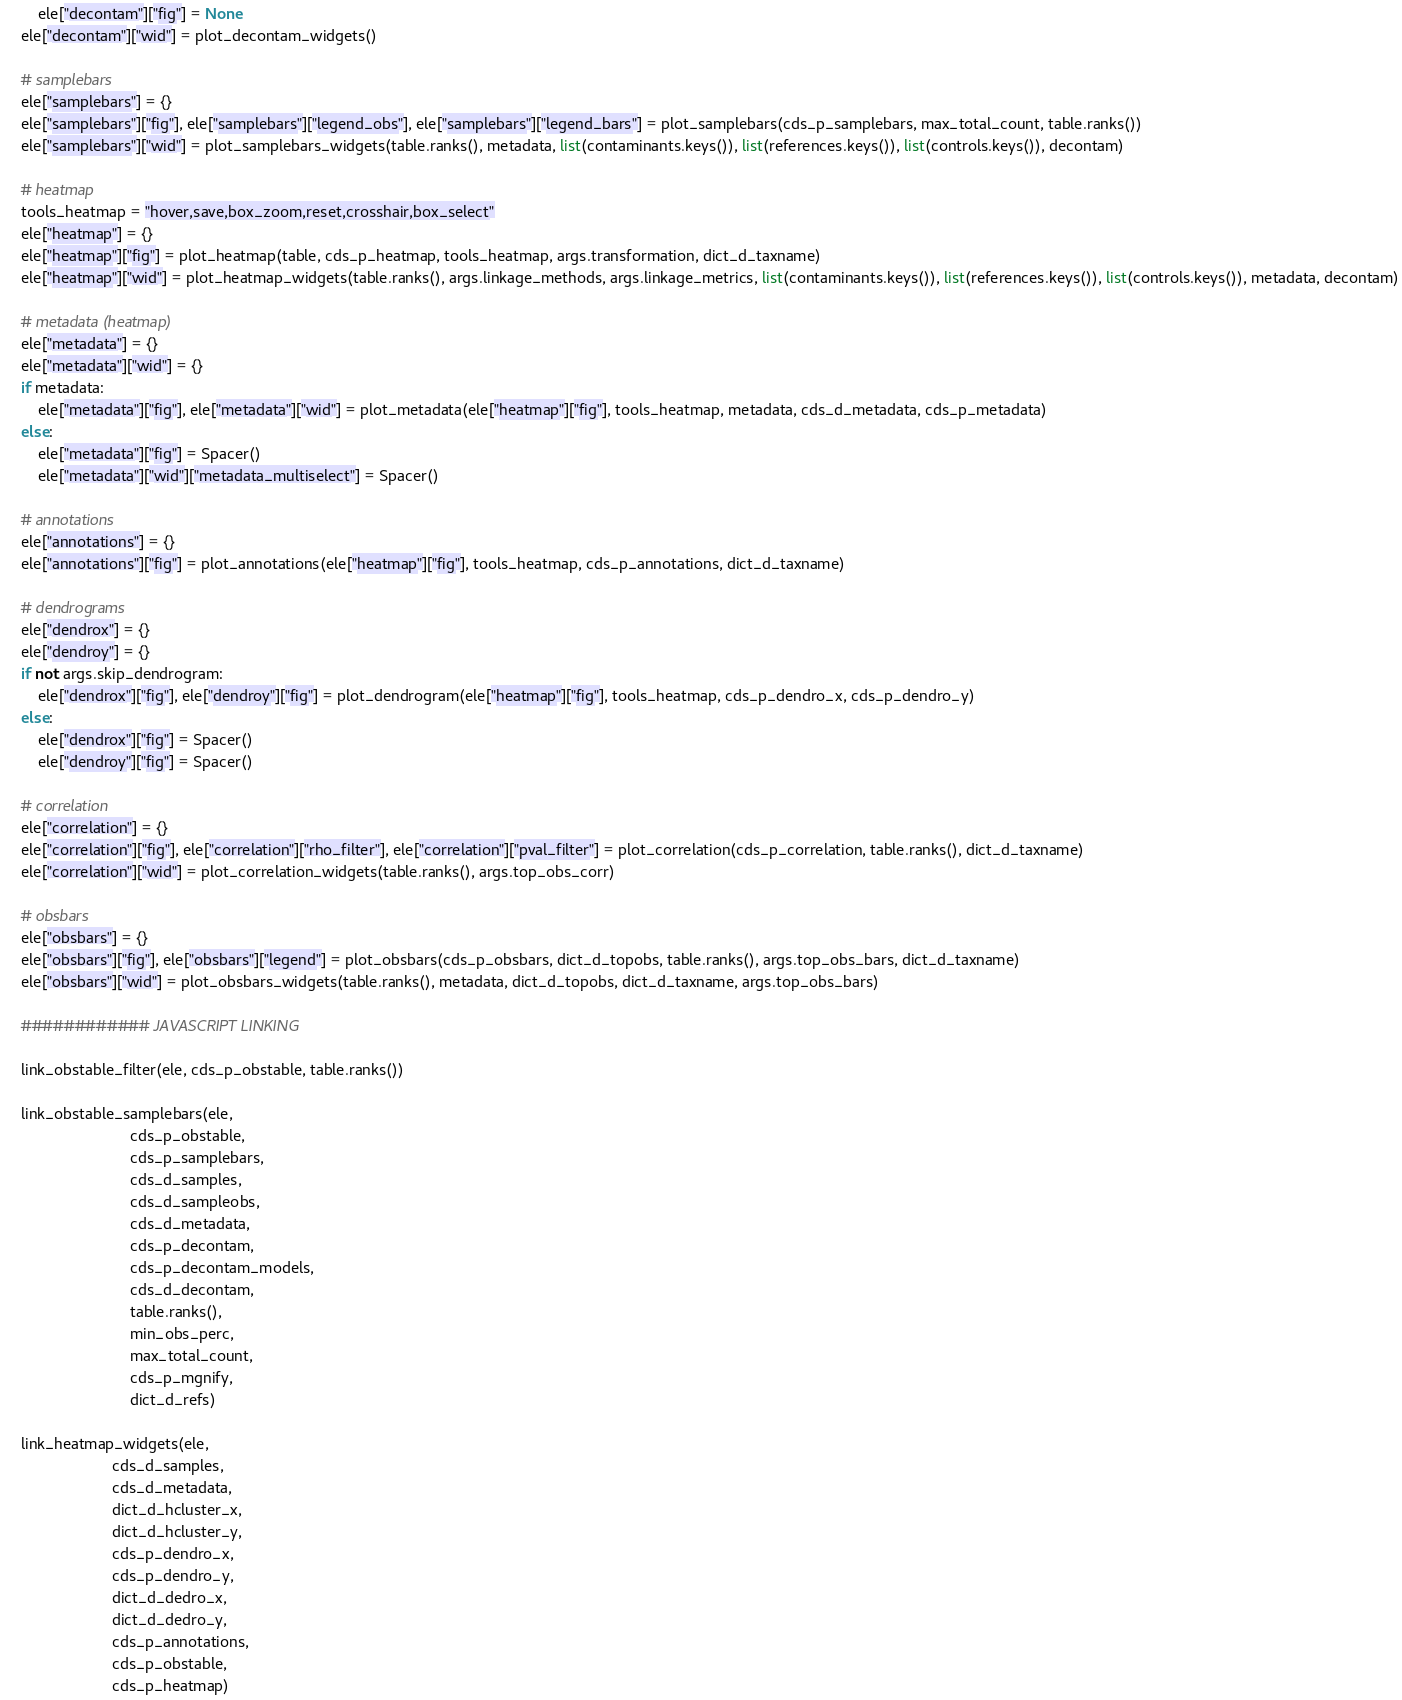Convert code to text. <code><loc_0><loc_0><loc_500><loc_500><_Python_>        ele["decontam"]["fig"] = None
    ele["decontam"]["wid"] = plot_decontam_widgets()

    # samplebars
    ele["samplebars"] = {}
    ele["samplebars"]["fig"], ele["samplebars"]["legend_obs"], ele["samplebars"]["legend_bars"] = plot_samplebars(cds_p_samplebars, max_total_count, table.ranks())
    ele["samplebars"]["wid"] = plot_samplebars_widgets(table.ranks(), metadata, list(contaminants.keys()), list(references.keys()), list(controls.keys()), decontam)

    # heatmap
    tools_heatmap = "hover,save,box_zoom,reset,crosshair,box_select"
    ele["heatmap"] = {}
    ele["heatmap"]["fig"] = plot_heatmap(table, cds_p_heatmap, tools_heatmap, args.transformation, dict_d_taxname)
    ele["heatmap"]["wid"] = plot_heatmap_widgets(table.ranks(), args.linkage_methods, args.linkage_metrics, list(contaminants.keys()), list(references.keys()), list(controls.keys()), metadata, decontam)

    # metadata (heatmap)
    ele["metadata"] = {}
    ele["metadata"]["wid"] = {}
    if metadata:
        ele["metadata"]["fig"], ele["metadata"]["wid"] = plot_metadata(ele["heatmap"]["fig"], tools_heatmap, metadata, cds_d_metadata, cds_p_metadata)
    else:
        ele["metadata"]["fig"] = Spacer()
        ele["metadata"]["wid"]["metadata_multiselect"] = Spacer()

    # annotations
    ele["annotations"] = {}
    ele["annotations"]["fig"] = plot_annotations(ele["heatmap"]["fig"], tools_heatmap, cds_p_annotations, dict_d_taxname)

    # dendrograms
    ele["dendrox"] = {}
    ele["dendroy"] = {}
    if not args.skip_dendrogram:
        ele["dendrox"]["fig"], ele["dendroy"]["fig"] = plot_dendrogram(ele["heatmap"]["fig"], tools_heatmap, cds_p_dendro_x, cds_p_dendro_y)
    else:
        ele["dendrox"]["fig"] = Spacer()
        ele["dendroy"]["fig"] = Spacer()

    # correlation
    ele["correlation"] = {}
    ele["correlation"]["fig"], ele["correlation"]["rho_filter"], ele["correlation"]["pval_filter"] = plot_correlation(cds_p_correlation, table.ranks(), dict_d_taxname)
    ele["correlation"]["wid"] = plot_correlation_widgets(table.ranks(), args.top_obs_corr)

    # obsbars
    ele["obsbars"] = {}
    ele["obsbars"]["fig"], ele["obsbars"]["legend"] = plot_obsbars(cds_p_obsbars, dict_d_topobs, table.ranks(), args.top_obs_bars, dict_d_taxname)
    ele["obsbars"]["wid"] = plot_obsbars_widgets(table.ranks(), metadata, dict_d_topobs, dict_d_taxname, args.top_obs_bars)

    ############ JAVASCRIPT LINKING

    link_obstable_filter(ele, cds_p_obstable, table.ranks())

    link_obstable_samplebars(ele,
                             cds_p_obstable,
                             cds_p_samplebars,
                             cds_d_samples,
                             cds_d_sampleobs,
                             cds_d_metadata,
                             cds_p_decontam,
                             cds_p_decontam_models,
                             cds_d_decontam,
                             table.ranks(),
                             min_obs_perc,
                             max_total_count,
                             cds_p_mgnify,
                             dict_d_refs)

    link_heatmap_widgets(ele,
                         cds_d_samples,
                         cds_d_metadata,
                         dict_d_hcluster_x,
                         dict_d_hcluster_y,
                         cds_p_dendro_x,
                         cds_p_dendro_y,
                         dict_d_dedro_x,
                         dict_d_dedro_y,
                         cds_p_annotations,
                         cds_p_obstable,
                         cds_p_heatmap)
</code> 